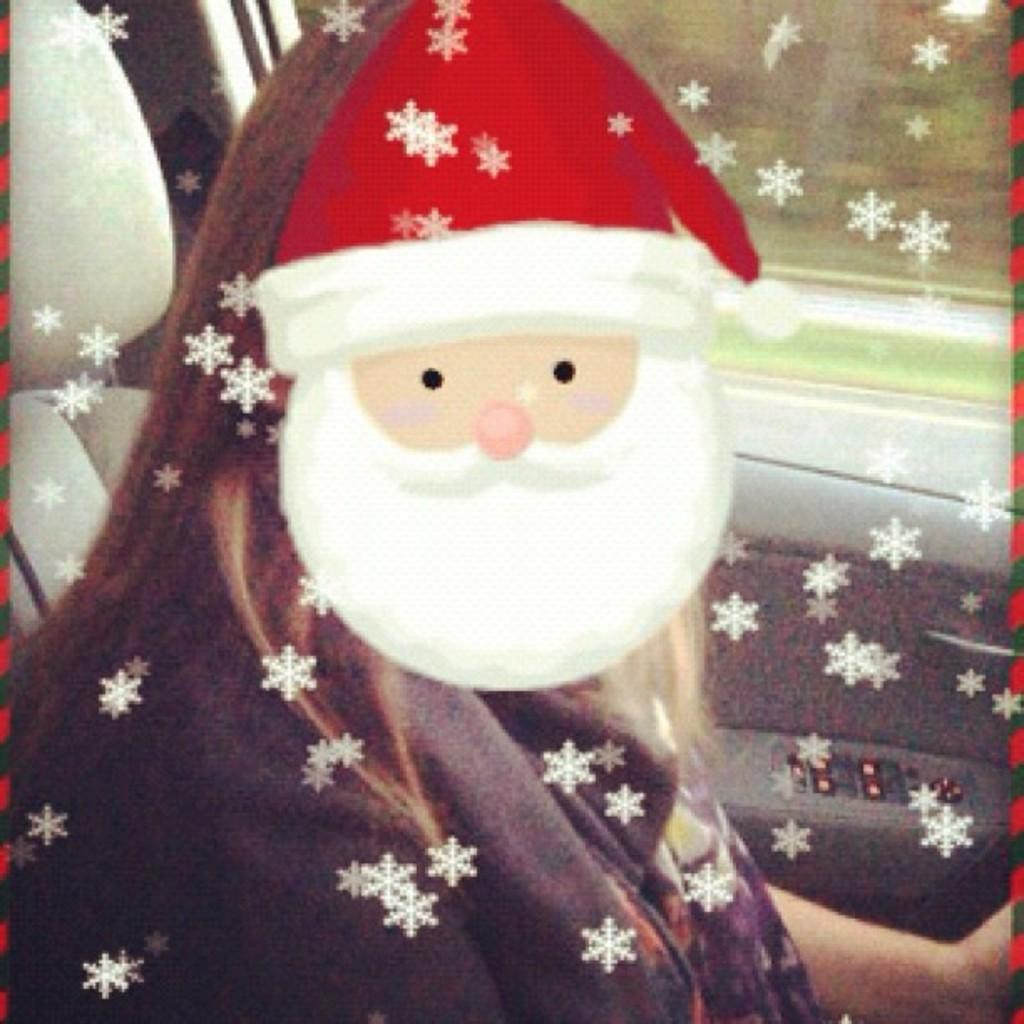What is the person in the image doing? The person is sitting in a car in the image. Can you describe any other notable features in the image? Yes, there is a cartoon face in the image. What type of hat is the goose wearing in the image? There is no goose or hat present in the image. Is there a bridge visible in the image? No, there is no bridge visible in the image. 